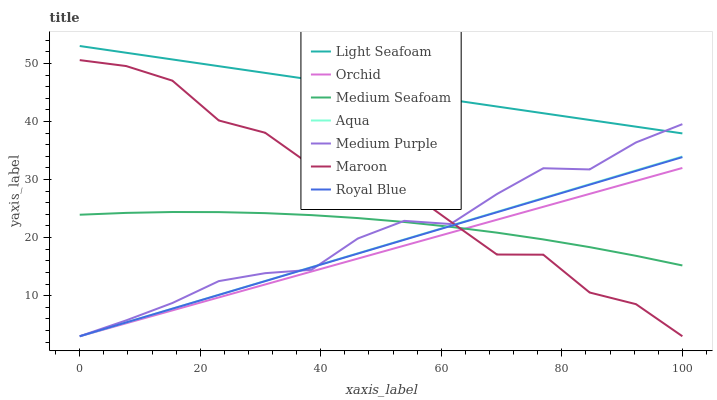Does Maroon have the minimum area under the curve?
Answer yes or no. No. Does Maroon have the maximum area under the curve?
Answer yes or no. No. Is Medium Purple the smoothest?
Answer yes or no. No. Is Medium Purple the roughest?
Answer yes or no. No. Does Light Seafoam have the lowest value?
Answer yes or no. No. Does Maroon have the highest value?
Answer yes or no. No. Is Royal Blue less than Light Seafoam?
Answer yes or no. Yes. Is Light Seafoam greater than Maroon?
Answer yes or no. Yes. Does Royal Blue intersect Light Seafoam?
Answer yes or no. No. 